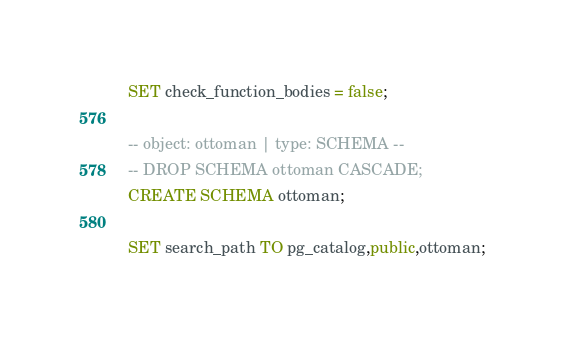<code> <loc_0><loc_0><loc_500><loc_500><_SQL_>SET check_function_bodies = false;

-- object: ottoman | type: SCHEMA --
-- DROP SCHEMA ottoman CASCADE;
CREATE SCHEMA ottoman;

SET search_path TO pg_catalog,public,ottoman;
</code> 